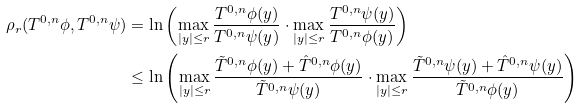<formula> <loc_0><loc_0><loc_500><loc_500>\rho _ { r } ( T ^ { 0 , n } \phi , T ^ { 0 , n } \psi ) & = \ln \left ( \max _ { | y | \leq r } \frac { T ^ { 0 , n } \phi ( y ) } { T ^ { 0 , n } \psi ( y ) } \cdot \max _ { | y | \leq r } \frac { T ^ { 0 , n } \psi ( y ) } { T ^ { 0 , n } \phi ( y ) } \right ) \\ & \leq \ln \left ( \max _ { | y | \leq r } \frac { \tilde { T } ^ { 0 , n } \phi ( y ) + \hat { T } ^ { 0 , n } \phi ( y ) } { \tilde { T } ^ { 0 , n } \psi ( y ) } \cdot \max _ { | y | \leq r } \frac { \tilde { T } ^ { 0 , n } \psi ( y ) + \hat { T } ^ { 0 , n } \psi ( y ) } { \tilde { T } ^ { 0 , n } \phi ( y ) } \right )</formula> 